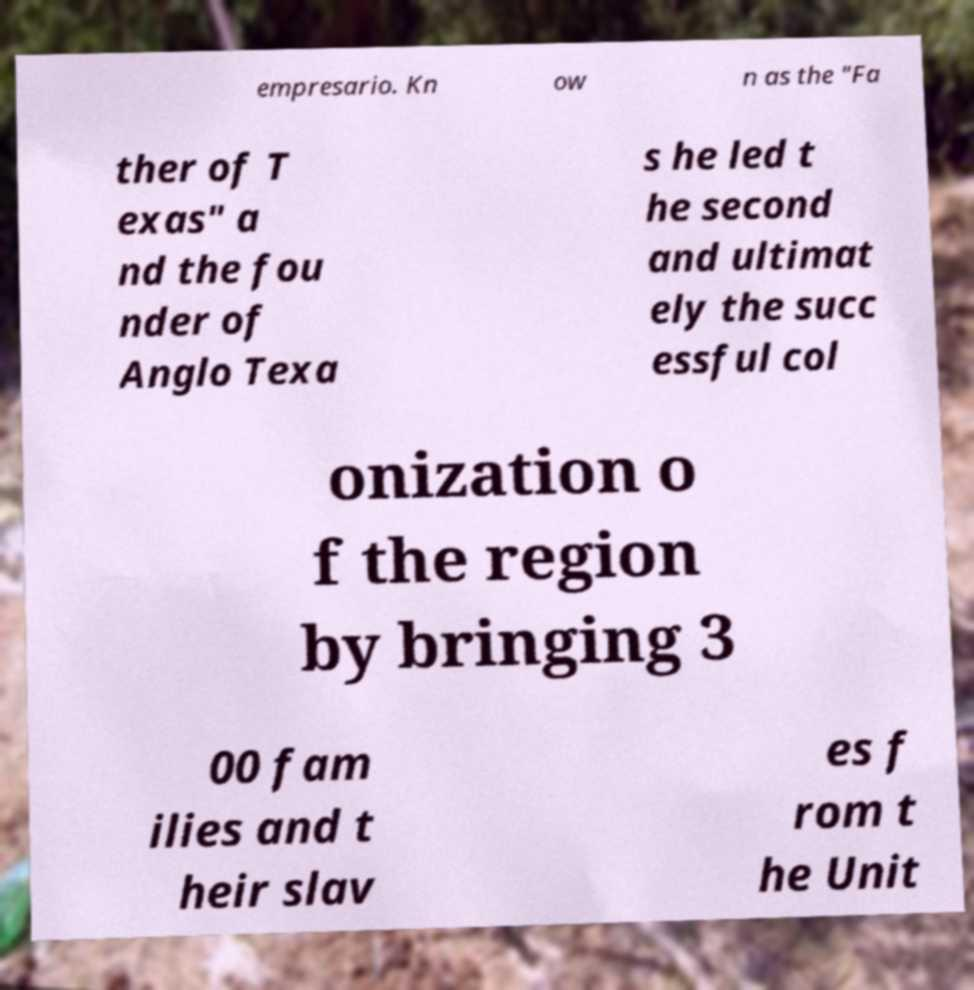I need the written content from this picture converted into text. Can you do that? empresario. Kn ow n as the "Fa ther of T exas" a nd the fou nder of Anglo Texa s he led t he second and ultimat ely the succ essful col onization o f the region by bringing 3 00 fam ilies and t heir slav es f rom t he Unit 